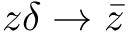Convert formula to latex. <formula><loc_0><loc_0><loc_500><loc_500>z \delta \rightarrow \bar { z }</formula> 